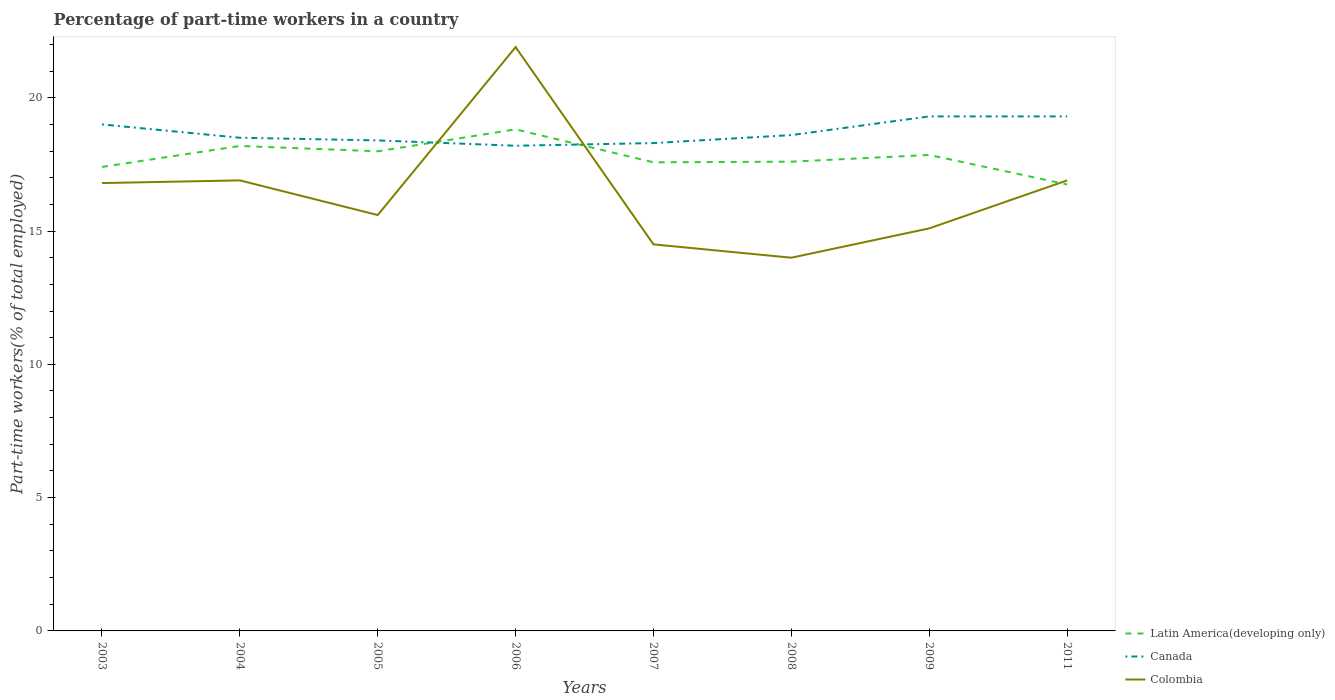How many different coloured lines are there?
Offer a terse response. 3. Does the line corresponding to Latin America(developing only) intersect with the line corresponding to Colombia?
Offer a terse response. Yes. Is the number of lines equal to the number of legend labels?
Offer a terse response. Yes. Across all years, what is the maximum percentage of part-time workers in Canada?
Your answer should be compact. 18.2. What is the total percentage of part-time workers in Colombia in the graph?
Ensure brevity in your answer.  2.9. What is the difference between the highest and the second highest percentage of part-time workers in Latin America(developing only)?
Offer a terse response. 2.07. How many lines are there?
Your response must be concise. 3. Does the graph contain any zero values?
Your answer should be very brief. No. How are the legend labels stacked?
Ensure brevity in your answer.  Vertical. What is the title of the graph?
Your answer should be very brief. Percentage of part-time workers in a country. What is the label or title of the Y-axis?
Ensure brevity in your answer.  Part-time workers(% of total employed). What is the Part-time workers(% of total employed) in Latin America(developing only) in 2003?
Make the answer very short. 17.4. What is the Part-time workers(% of total employed) in Canada in 2003?
Give a very brief answer. 19. What is the Part-time workers(% of total employed) of Colombia in 2003?
Make the answer very short. 16.8. What is the Part-time workers(% of total employed) of Latin America(developing only) in 2004?
Offer a very short reply. 18.19. What is the Part-time workers(% of total employed) in Canada in 2004?
Provide a succinct answer. 18.5. What is the Part-time workers(% of total employed) of Colombia in 2004?
Provide a short and direct response. 16.9. What is the Part-time workers(% of total employed) in Latin America(developing only) in 2005?
Give a very brief answer. 17.99. What is the Part-time workers(% of total employed) in Canada in 2005?
Ensure brevity in your answer.  18.4. What is the Part-time workers(% of total employed) in Colombia in 2005?
Offer a very short reply. 15.6. What is the Part-time workers(% of total employed) in Latin America(developing only) in 2006?
Provide a succinct answer. 18.81. What is the Part-time workers(% of total employed) in Canada in 2006?
Keep it short and to the point. 18.2. What is the Part-time workers(% of total employed) in Colombia in 2006?
Provide a succinct answer. 21.9. What is the Part-time workers(% of total employed) in Latin America(developing only) in 2007?
Offer a very short reply. 17.58. What is the Part-time workers(% of total employed) of Canada in 2007?
Provide a short and direct response. 18.3. What is the Part-time workers(% of total employed) in Latin America(developing only) in 2008?
Your response must be concise. 17.6. What is the Part-time workers(% of total employed) in Canada in 2008?
Your answer should be very brief. 18.6. What is the Part-time workers(% of total employed) in Colombia in 2008?
Give a very brief answer. 14. What is the Part-time workers(% of total employed) of Latin America(developing only) in 2009?
Ensure brevity in your answer.  17.85. What is the Part-time workers(% of total employed) of Canada in 2009?
Offer a very short reply. 19.3. What is the Part-time workers(% of total employed) in Colombia in 2009?
Your answer should be compact. 15.1. What is the Part-time workers(% of total employed) of Latin America(developing only) in 2011?
Your answer should be compact. 16.75. What is the Part-time workers(% of total employed) of Canada in 2011?
Make the answer very short. 19.3. What is the Part-time workers(% of total employed) in Colombia in 2011?
Your answer should be compact. 16.9. Across all years, what is the maximum Part-time workers(% of total employed) in Latin America(developing only)?
Provide a succinct answer. 18.81. Across all years, what is the maximum Part-time workers(% of total employed) of Canada?
Offer a terse response. 19.3. Across all years, what is the maximum Part-time workers(% of total employed) in Colombia?
Offer a terse response. 21.9. Across all years, what is the minimum Part-time workers(% of total employed) of Latin America(developing only)?
Offer a very short reply. 16.75. Across all years, what is the minimum Part-time workers(% of total employed) in Canada?
Your response must be concise. 18.2. What is the total Part-time workers(% of total employed) in Latin America(developing only) in the graph?
Your response must be concise. 142.19. What is the total Part-time workers(% of total employed) of Canada in the graph?
Make the answer very short. 149.6. What is the total Part-time workers(% of total employed) of Colombia in the graph?
Provide a succinct answer. 131.7. What is the difference between the Part-time workers(% of total employed) in Latin America(developing only) in 2003 and that in 2004?
Provide a short and direct response. -0.79. What is the difference between the Part-time workers(% of total employed) of Canada in 2003 and that in 2004?
Provide a succinct answer. 0.5. What is the difference between the Part-time workers(% of total employed) in Latin America(developing only) in 2003 and that in 2005?
Your response must be concise. -0.59. What is the difference between the Part-time workers(% of total employed) of Canada in 2003 and that in 2005?
Offer a very short reply. 0.6. What is the difference between the Part-time workers(% of total employed) in Colombia in 2003 and that in 2005?
Offer a very short reply. 1.2. What is the difference between the Part-time workers(% of total employed) of Latin America(developing only) in 2003 and that in 2006?
Your answer should be very brief. -1.41. What is the difference between the Part-time workers(% of total employed) in Canada in 2003 and that in 2006?
Your answer should be very brief. 0.8. What is the difference between the Part-time workers(% of total employed) in Latin America(developing only) in 2003 and that in 2007?
Keep it short and to the point. -0.17. What is the difference between the Part-time workers(% of total employed) in Colombia in 2003 and that in 2007?
Offer a very short reply. 2.3. What is the difference between the Part-time workers(% of total employed) of Latin America(developing only) in 2003 and that in 2008?
Provide a short and direct response. -0.2. What is the difference between the Part-time workers(% of total employed) of Canada in 2003 and that in 2008?
Offer a terse response. 0.4. What is the difference between the Part-time workers(% of total employed) in Colombia in 2003 and that in 2008?
Offer a terse response. 2.8. What is the difference between the Part-time workers(% of total employed) of Latin America(developing only) in 2003 and that in 2009?
Make the answer very short. -0.45. What is the difference between the Part-time workers(% of total employed) in Latin America(developing only) in 2003 and that in 2011?
Offer a terse response. 0.66. What is the difference between the Part-time workers(% of total employed) in Colombia in 2003 and that in 2011?
Offer a very short reply. -0.1. What is the difference between the Part-time workers(% of total employed) in Latin America(developing only) in 2004 and that in 2005?
Make the answer very short. 0.2. What is the difference between the Part-time workers(% of total employed) in Canada in 2004 and that in 2005?
Make the answer very short. 0.1. What is the difference between the Part-time workers(% of total employed) in Latin America(developing only) in 2004 and that in 2006?
Provide a short and direct response. -0.62. What is the difference between the Part-time workers(% of total employed) of Canada in 2004 and that in 2006?
Your response must be concise. 0.3. What is the difference between the Part-time workers(% of total employed) in Colombia in 2004 and that in 2006?
Make the answer very short. -5. What is the difference between the Part-time workers(% of total employed) of Latin America(developing only) in 2004 and that in 2007?
Make the answer very short. 0.61. What is the difference between the Part-time workers(% of total employed) in Latin America(developing only) in 2004 and that in 2008?
Make the answer very short. 0.59. What is the difference between the Part-time workers(% of total employed) of Colombia in 2004 and that in 2008?
Provide a succinct answer. 2.9. What is the difference between the Part-time workers(% of total employed) of Latin America(developing only) in 2004 and that in 2009?
Make the answer very short. 0.34. What is the difference between the Part-time workers(% of total employed) in Canada in 2004 and that in 2009?
Your answer should be compact. -0.8. What is the difference between the Part-time workers(% of total employed) of Latin America(developing only) in 2004 and that in 2011?
Offer a very short reply. 1.44. What is the difference between the Part-time workers(% of total employed) in Canada in 2004 and that in 2011?
Provide a succinct answer. -0.8. What is the difference between the Part-time workers(% of total employed) of Colombia in 2004 and that in 2011?
Make the answer very short. 0. What is the difference between the Part-time workers(% of total employed) in Latin America(developing only) in 2005 and that in 2006?
Offer a very short reply. -0.82. What is the difference between the Part-time workers(% of total employed) of Latin America(developing only) in 2005 and that in 2007?
Offer a terse response. 0.41. What is the difference between the Part-time workers(% of total employed) in Canada in 2005 and that in 2007?
Make the answer very short. 0.1. What is the difference between the Part-time workers(% of total employed) of Colombia in 2005 and that in 2007?
Ensure brevity in your answer.  1.1. What is the difference between the Part-time workers(% of total employed) in Latin America(developing only) in 2005 and that in 2008?
Your answer should be compact. 0.39. What is the difference between the Part-time workers(% of total employed) in Canada in 2005 and that in 2008?
Keep it short and to the point. -0.2. What is the difference between the Part-time workers(% of total employed) of Colombia in 2005 and that in 2008?
Provide a short and direct response. 1.6. What is the difference between the Part-time workers(% of total employed) of Latin America(developing only) in 2005 and that in 2009?
Provide a succinct answer. 0.14. What is the difference between the Part-time workers(% of total employed) of Canada in 2005 and that in 2009?
Your answer should be very brief. -0.9. What is the difference between the Part-time workers(% of total employed) in Latin America(developing only) in 2005 and that in 2011?
Make the answer very short. 1.24. What is the difference between the Part-time workers(% of total employed) in Colombia in 2005 and that in 2011?
Provide a short and direct response. -1.3. What is the difference between the Part-time workers(% of total employed) of Latin America(developing only) in 2006 and that in 2007?
Offer a very short reply. 1.24. What is the difference between the Part-time workers(% of total employed) of Colombia in 2006 and that in 2007?
Give a very brief answer. 7.4. What is the difference between the Part-time workers(% of total employed) of Latin America(developing only) in 2006 and that in 2008?
Offer a very short reply. 1.21. What is the difference between the Part-time workers(% of total employed) in Canada in 2006 and that in 2008?
Make the answer very short. -0.4. What is the difference between the Part-time workers(% of total employed) in Latin America(developing only) in 2006 and that in 2009?
Your answer should be very brief. 0.96. What is the difference between the Part-time workers(% of total employed) of Colombia in 2006 and that in 2009?
Provide a succinct answer. 6.8. What is the difference between the Part-time workers(% of total employed) of Latin America(developing only) in 2006 and that in 2011?
Provide a short and direct response. 2.07. What is the difference between the Part-time workers(% of total employed) of Colombia in 2006 and that in 2011?
Offer a terse response. 5. What is the difference between the Part-time workers(% of total employed) of Latin America(developing only) in 2007 and that in 2008?
Your response must be concise. -0.02. What is the difference between the Part-time workers(% of total employed) in Colombia in 2007 and that in 2008?
Your answer should be compact. 0.5. What is the difference between the Part-time workers(% of total employed) of Latin America(developing only) in 2007 and that in 2009?
Provide a succinct answer. -0.27. What is the difference between the Part-time workers(% of total employed) of Colombia in 2007 and that in 2009?
Keep it short and to the point. -0.6. What is the difference between the Part-time workers(% of total employed) of Latin America(developing only) in 2007 and that in 2011?
Your answer should be very brief. 0.83. What is the difference between the Part-time workers(% of total employed) in Canada in 2007 and that in 2011?
Make the answer very short. -1. What is the difference between the Part-time workers(% of total employed) in Colombia in 2007 and that in 2011?
Provide a short and direct response. -2.4. What is the difference between the Part-time workers(% of total employed) in Latin America(developing only) in 2008 and that in 2009?
Offer a very short reply. -0.25. What is the difference between the Part-time workers(% of total employed) in Canada in 2008 and that in 2009?
Ensure brevity in your answer.  -0.7. What is the difference between the Part-time workers(% of total employed) in Latin America(developing only) in 2008 and that in 2011?
Ensure brevity in your answer.  0.85. What is the difference between the Part-time workers(% of total employed) in Canada in 2008 and that in 2011?
Keep it short and to the point. -0.7. What is the difference between the Part-time workers(% of total employed) of Colombia in 2008 and that in 2011?
Offer a terse response. -2.9. What is the difference between the Part-time workers(% of total employed) of Latin America(developing only) in 2009 and that in 2011?
Your response must be concise. 1.11. What is the difference between the Part-time workers(% of total employed) of Colombia in 2009 and that in 2011?
Keep it short and to the point. -1.8. What is the difference between the Part-time workers(% of total employed) of Latin America(developing only) in 2003 and the Part-time workers(% of total employed) of Canada in 2004?
Provide a short and direct response. -1.1. What is the difference between the Part-time workers(% of total employed) of Latin America(developing only) in 2003 and the Part-time workers(% of total employed) of Colombia in 2004?
Provide a short and direct response. 0.5. What is the difference between the Part-time workers(% of total employed) in Latin America(developing only) in 2003 and the Part-time workers(% of total employed) in Canada in 2005?
Ensure brevity in your answer.  -1. What is the difference between the Part-time workers(% of total employed) in Latin America(developing only) in 2003 and the Part-time workers(% of total employed) in Colombia in 2005?
Give a very brief answer. 1.8. What is the difference between the Part-time workers(% of total employed) of Latin America(developing only) in 2003 and the Part-time workers(% of total employed) of Canada in 2006?
Ensure brevity in your answer.  -0.8. What is the difference between the Part-time workers(% of total employed) of Latin America(developing only) in 2003 and the Part-time workers(% of total employed) of Colombia in 2006?
Your answer should be very brief. -4.5. What is the difference between the Part-time workers(% of total employed) of Latin America(developing only) in 2003 and the Part-time workers(% of total employed) of Canada in 2007?
Make the answer very short. -0.9. What is the difference between the Part-time workers(% of total employed) of Latin America(developing only) in 2003 and the Part-time workers(% of total employed) of Colombia in 2007?
Your answer should be very brief. 2.9. What is the difference between the Part-time workers(% of total employed) of Canada in 2003 and the Part-time workers(% of total employed) of Colombia in 2007?
Provide a short and direct response. 4.5. What is the difference between the Part-time workers(% of total employed) in Latin America(developing only) in 2003 and the Part-time workers(% of total employed) in Canada in 2008?
Your answer should be very brief. -1.2. What is the difference between the Part-time workers(% of total employed) of Latin America(developing only) in 2003 and the Part-time workers(% of total employed) of Colombia in 2008?
Keep it short and to the point. 3.4. What is the difference between the Part-time workers(% of total employed) of Latin America(developing only) in 2003 and the Part-time workers(% of total employed) of Canada in 2009?
Offer a very short reply. -1.9. What is the difference between the Part-time workers(% of total employed) in Latin America(developing only) in 2003 and the Part-time workers(% of total employed) in Colombia in 2009?
Your response must be concise. 2.3. What is the difference between the Part-time workers(% of total employed) in Canada in 2003 and the Part-time workers(% of total employed) in Colombia in 2009?
Provide a succinct answer. 3.9. What is the difference between the Part-time workers(% of total employed) of Latin America(developing only) in 2003 and the Part-time workers(% of total employed) of Canada in 2011?
Your answer should be very brief. -1.9. What is the difference between the Part-time workers(% of total employed) in Latin America(developing only) in 2003 and the Part-time workers(% of total employed) in Colombia in 2011?
Your answer should be compact. 0.5. What is the difference between the Part-time workers(% of total employed) of Canada in 2003 and the Part-time workers(% of total employed) of Colombia in 2011?
Give a very brief answer. 2.1. What is the difference between the Part-time workers(% of total employed) of Latin America(developing only) in 2004 and the Part-time workers(% of total employed) of Canada in 2005?
Give a very brief answer. -0.21. What is the difference between the Part-time workers(% of total employed) of Latin America(developing only) in 2004 and the Part-time workers(% of total employed) of Colombia in 2005?
Provide a short and direct response. 2.59. What is the difference between the Part-time workers(% of total employed) of Latin America(developing only) in 2004 and the Part-time workers(% of total employed) of Canada in 2006?
Offer a terse response. -0.01. What is the difference between the Part-time workers(% of total employed) of Latin America(developing only) in 2004 and the Part-time workers(% of total employed) of Colombia in 2006?
Keep it short and to the point. -3.71. What is the difference between the Part-time workers(% of total employed) of Canada in 2004 and the Part-time workers(% of total employed) of Colombia in 2006?
Give a very brief answer. -3.4. What is the difference between the Part-time workers(% of total employed) of Latin America(developing only) in 2004 and the Part-time workers(% of total employed) of Canada in 2007?
Keep it short and to the point. -0.11. What is the difference between the Part-time workers(% of total employed) of Latin America(developing only) in 2004 and the Part-time workers(% of total employed) of Colombia in 2007?
Your answer should be compact. 3.69. What is the difference between the Part-time workers(% of total employed) in Canada in 2004 and the Part-time workers(% of total employed) in Colombia in 2007?
Your response must be concise. 4. What is the difference between the Part-time workers(% of total employed) of Latin America(developing only) in 2004 and the Part-time workers(% of total employed) of Canada in 2008?
Your response must be concise. -0.41. What is the difference between the Part-time workers(% of total employed) in Latin America(developing only) in 2004 and the Part-time workers(% of total employed) in Colombia in 2008?
Keep it short and to the point. 4.19. What is the difference between the Part-time workers(% of total employed) of Canada in 2004 and the Part-time workers(% of total employed) of Colombia in 2008?
Give a very brief answer. 4.5. What is the difference between the Part-time workers(% of total employed) of Latin America(developing only) in 2004 and the Part-time workers(% of total employed) of Canada in 2009?
Provide a short and direct response. -1.11. What is the difference between the Part-time workers(% of total employed) in Latin America(developing only) in 2004 and the Part-time workers(% of total employed) in Colombia in 2009?
Your answer should be very brief. 3.09. What is the difference between the Part-time workers(% of total employed) of Canada in 2004 and the Part-time workers(% of total employed) of Colombia in 2009?
Offer a very short reply. 3.4. What is the difference between the Part-time workers(% of total employed) in Latin America(developing only) in 2004 and the Part-time workers(% of total employed) in Canada in 2011?
Your answer should be very brief. -1.11. What is the difference between the Part-time workers(% of total employed) of Latin America(developing only) in 2004 and the Part-time workers(% of total employed) of Colombia in 2011?
Offer a terse response. 1.29. What is the difference between the Part-time workers(% of total employed) of Canada in 2004 and the Part-time workers(% of total employed) of Colombia in 2011?
Your answer should be very brief. 1.6. What is the difference between the Part-time workers(% of total employed) of Latin America(developing only) in 2005 and the Part-time workers(% of total employed) of Canada in 2006?
Give a very brief answer. -0.21. What is the difference between the Part-time workers(% of total employed) in Latin America(developing only) in 2005 and the Part-time workers(% of total employed) in Colombia in 2006?
Make the answer very short. -3.91. What is the difference between the Part-time workers(% of total employed) of Canada in 2005 and the Part-time workers(% of total employed) of Colombia in 2006?
Give a very brief answer. -3.5. What is the difference between the Part-time workers(% of total employed) of Latin America(developing only) in 2005 and the Part-time workers(% of total employed) of Canada in 2007?
Provide a succinct answer. -0.31. What is the difference between the Part-time workers(% of total employed) of Latin America(developing only) in 2005 and the Part-time workers(% of total employed) of Colombia in 2007?
Ensure brevity in your answer.  3.49. What is the difference between the Part-time workers(% of total employed) in Latin America(developing only) in 2005 and the Part-time workers(% of total employed) in Canada in 2008?
Keep it short and to the point. -0.61. What is the difference between the Part-time workers(% of total employed) of Latin America(developing only) in 2005 and the Part-time workers(% of total employed) of Colombia in 2008?
Offer a very short reply. 3.99. What is the difference between the Part-time workers(% of total employed) of Latin America(developing only) in 2005 and the Part-time workers(% of total employed) of Canada in 2009?
Your answer should be compact. -1.31. What is the difference between the Part-time workers(% of total employed) in Latin America(developing only) in 2005 and the Part-time workers(% of total employed) in Colombia in 2009?
Your answer should be very brief. 2.89. What is the difference between the Part-time workers(% of total employed) in Canada in 2005 and the Part-time workers(% of total employed) in Colombia in 2009?
Ensure brevity in your answer.  3.3. What is the difference between the Part-time workers(% of total employed) of Latin America(developing only) in 2005 and the Part-time workers(% of total employed) of Canada in 2011?
Offer a terse response. -1.31. What is the difference between the Part-time workers(% of total employed) in Latin America(developing only) in 2005 and the Part-time workers(% of total employed) in Colombia in 2011?
Your answer should be very brief. 1.09. What is the difference between the Part-time workers(% of total employed) in Canada in 2005 and the Part-time workers(% of total employed) in Colombia in 2011?
Your answer should be very brief. 1.5. What is the difference between the Part-time workers(% of total employed) in Latin America(developing only) in 2006 and the Part-time workers(% of total employed) in Canada in 2007?
Your answer should be very brief. 0.51. What is the difference between the Part-time workers(% of total employed) of Latin America(developing only) in 2006 and the Part-time workers(% of total employed) of Colombia in 2007?
Your answer should be very brief. 4.31. What is the difference between the Part-time workers(% of total employed) in Latin America(developing only) in 2006 and the Part-time workers(% of total employed) in Canada in 2008?
Give a very brief answer. 0.21. What is the difference between the Part-time workers(% of total employed) of Latin America(developing only) in 2006 and the Part-time workers(% of total employed) of Colombia in 2008?
Keep it short and to the point. 4.81. What is the difference between the Part-time workers(% of total employed) in Latin America(developing only) in 2006 and the Part-time workers(% of total employed) in Canada in 2009?
Your answer should be very brief. -0.49. What is the difference between the Part-time workers(% of total employed) of Latin America(developing only) in 2006 and the Part-time workers(% of total employed) of Colombia in 2009?
Ensure brevity in your answer.  3.71. What is the difference between the Part-time workers(% of total employed) in Canada in 2006 and the Part-time workers(% of total employed) in Colombia in 2009?
Your answer should be compact. 3.1. What is the difference between the Part-time workers(% of total employed) of Latin America(developing only) in 2006 and the Part-time workers(% of total employed) of Canada in 2011?
Your answer should be compact. -0.49. What is the difference between the Part-time workers(% of total employed) in Latin America(developing only) in 2006 and the Part-time workers(% of total employed) in Colombia in 2011?
Ensure brevity in your answer.  1.91. What is the difference between the Part-time workers(% of total employed) in Canada in 2006 and the Part-time workers(% of total employed) in Colombia in 2011?
Ensure brevity in your answer.  1.3. What is the difference between the Part-time workers(% of total employed) in Latin America(developing only) in 2007 and the Part-time workers(% of total employed) in Canada in 2008?
Give a very brief answer. -1.02. What is the difference between the Part-time workers(% of total employed) of Latin America(developing only) in 2007 and the Part-time workers(% of total employed) of Colombia in 2008?
Your response must be concise. 3.58. What is the difference between the Part-time workers(% of total employed) in Latin America(developing only) in 2007 and the Part-time workers(% of total employed) in Canada in 2009?
Give a very brief answer. -1.72. What is the difference between the Part-time workers(% of total employed) of Latin America(developing only) in 2007 and the Part-time workers(% of total employed) of Colombia in 2009?
Offer a very short reply. 2.48. What is the difference between the Part-time workers(% of total employed) of Canada in 2007 and the Part-time workers(% of total employed) of Colombia in 2009?
Provide a short and direct response. 3.2. What is the difference between the Part-time workers(% of total employed) in Latin America(developing only) in 2007 and the Part-time workers(% of total employed) in Canada in 2011?
Your answer should be very brief. -1.72. What is the difference between the Part-time workers(% of total employed) of Latin America(developing only) in 2007 and the Part-time workers(% of total employed) of Colombia in 2011?
Make the answer very short. 0.68. What is the difference between the Part-time workers(% of total employed) in Canada in 2007 and the Part-time workers(% of total employed) in Colombia in 2011?
Offer a very short reply. 1.4. What is the difference between the Part-time workers(% of total employed) of Latin America(developing only) in 2008 and the Part-time workers(% of total employed) of Canada in 2009?
Keep it short and to the point. -1.7. What is the difference between the Part-time workers(% of total employed) in Latin America(developing only) in 2008 and the Part-time workers(% of total employed) in Colombia in 2009?
Your answer should be very brief. 2.5. What is the difference between the Part-time workers(% of total employed) in Latin America(developing only) in 2008 and the Part-time workers(% of total employed) in Canada in 2011?
Keep it short and to the point. -1.7. What is the difference between the Part-time workers(% of total employed) in Latin America(developing only) in 2008 and the Part-time workers(% of total employed) in Colombia in 2011?
Your answer should be very brief. 0.7. What is the difference between the Part-time workers(% of total employed) in Latin America(developing only) in 2009 and the Part-time workers(% of total employed) in Canada in 2011?
Provide a succinct answer. -1.45. What is the difference between the Part-time workers(% of total employed) in Latin America(developing only) in 2009 and the Part-time workers(% of total employed) in Colombia in 2011?
Offer a terse response. 0.95. What is the average Part-time workers(% of total employed) of Latin America(developing only) per year?
Make the answer very short. 17.77. What is the average Part-time workers(% of total employed) in Canada per year?
Your response must be concise. 18.7. What is the average Part-time workers(% of total employed) in Colombia per year?
Keep it short and to the point. 16.46. In the year 2003, what is the difference between the Part-time workers(% of total employed) in Latin America(developing only) and Part-time workers(% of total employed) in Canada?
Ensure brevity in your answer.  -1.6. In the year 2003, what is the difference between the Part-time workers(% of total employed) of Latin America(developing only) and Part-time workers(% of total employed) of Colombia?
Give a very brief answer. 0.6. In the year 2004, what is the difference between the Part-time workers(% of total employed) in Latin America(developing only) and Part-time workers(% of total employed) in Canada?
Ensure brevity in your answer.  -0.31. In the year 2004, what is the difference between the Part-time workers(% of total employed) of Latin America(developing only) and Part-time workers(% of total employed) of Colombia?
Your answer should be compact. 1.29. In the year 2004, what is the difference between the Part-time workers(% of total employed) in Canada and Part-time workers(% of total employed) in Colombia?
Offer a very short reply. 1.6. In the year 2005, what is the difference between the Part-time workers(% of total employed) of Latin America(developing only) and Part-time workers(% of total employed) of Canada?
Offer a very short reply. -0.41. In the year 2005, what is the difference between the Part-time workers(% of total employed) of Latin America(developing only) and Part-time workers(% of total employed) of Colombia?
Ensure brevity in your answer.  2.39. In the year 2005, what is the difference between the Part-time workers(% of total employed) of Canada and Part-time workers(% of total employed) of Colombia?
Give a very brief answer. 2.8. In the year 2006, what is the difference between the Part-time workers(% of total employed) in Latin America(developing only) and Part-time workers(% of total employed) in Canada?
Your answer should be compact. 0.61. In the year 2006, what is the difference between the Part-time workers(% of total employed) of Latin America(developing only) and Part-time workers(% of total employed) of Colombia?
Keep it short and to the point. -3.09. In the year 2006, what is the difference between the Part-time workers(% of total employed) in Canada and Part-time workers(% of total employed) in Colombia?
Your answer should be very brief. -3.7. In the year 2007, what is the difference between the Part-time workers(% of total employed) in Latin America(developing only) and Part-time workers(% of total employed) in Canada?
Make the answer very short. -0.72. In the year 2007, what is the difference between the Part-time workers(% of total employed) of Latin America(developing only) and Part-time workers(% of total employed) of Colombia?
Provide a short and direct response. 3.08. In the year 2007, what is the difference between the Part-time workers(% of total employed) in Canada and Part-time workers(% of total employed) in Colombia?
Make the answer very short. 3.8. In the year 2008, what is the difference between the Part-time workers(% of total employed) in Latin America(developing only) and Part-time workers(% of total employed) in Canada?
Make the answer very short. -1. In the year 2008, what is the difference between the Part-time workers(% of total employed) in Latin America(developing only) and Part-time workers(% of total employed) in Colombia?
Ensure brevity in your answer.  3.6. In the year 2008, what is the difference between the Part-time workers(% of total employed) of Canada and Part-time workers(% of total employed) of Colombia?
Your response must be concise. 4.6. In the year 2009, what is the difference between the Part-time workers(% of total employed) in Latin America(developing only) and Part-time workers(% of total employed) in Canada?
Give a very brief answer. -1.45. In the year 2009, what is the difference between the Part-time workers(% of total employed) in Latin America(developing only) and Part-time workers(% of total employed) in Colombia?
Provide a short and direct response. 2.75. In the year 2009, what is the difference between the Part-time workers(% of total employed) of Canada and Part-time workers(% of total employed) of Colombia?
Give a very brief answer. 4.2. In the year 2011, what is the difference between the Part-time workers(% of total employed) in Latin America(developing only) and Part-time workers(% of total employed) in Canada?
Offer a terse response. -2.55. In the year 2011, what is the difference between the Part-time workers(% of total employed) of Latin America(developing only) and Part-time workers(% of total employed) of Colombia?
Your response must be concise. -0.15. What is the ratio of the Part-time workers(% of total employed) in Latin America(developing only) in 2003 to that in 2004?
Offer a terse response. 0.96. What is the ratio of the Part-time workers(% of total employed) in Latin America(developing only) in 2003 to that in 2005?
Your answer should be very brief. 0.97. What is the ratio of the Part-time workers(% of total employed) of Canada in 2003 to that in 2005?
Your response must be concise. 1.03. What is the ratio of the Part-time workers(% of total employed) in Latin America(developing only) in 2003 to that in 2006?
Keep it short and to the point. 0.93. What is the ratio of the Part-time workers(% of total employed) in Canada in 2003 to that in 2006?
Offer a very short reply. 1.04. What is the ratio of the Part-time workers(% of total employed) in Colombia in 2003 to that in 2006?
Give a very brief answer. 0.77. What is the ratio of the Part-time workers(% of total employed) of Latin America(developing only) in 2003 to that in 2007?
Make the answer very short. 0.99. What is the ratio of the Part-time workers(% of total employed) of Canada in 2003 to that in 2007?
Your answer should be very brief. 1.04. What is the ratio of the Part-time workers(% of total employed) in Colombia in 2003 to that in 2007?
Keep it short and to the point. 1.16. What is the ratio of the Part-time workers(% of total employed) of Canada in 2003 to that in 2008?
Your response must be concise. 1.02. What is the ratio of the Part-time workers(% of total employed) of Latin America(developing only) in 2003 to that in 2009?
Make the answer very short. 0.97. What is the ratio of the Part-time workers(% of total employed) of Canada in 2003 to that in 2009?
Your answer should be compact. 0.98. What is the ratio of the Part-time workers(% of total employed) of Colombia in 2003 to that in 2009?
Provide a succinct answer. 1.11. What is the ratio of the Part-time workers(% of total employed) in Latin America(developing only) in 2003 to that in 2011?
Make the answer very short. 1.04. What is the ratio of the Part-time workers(% of total employed) of Canada in 2003 to that in 2011?
Offer a very short reply. 0.98. What is the ratio of the Part-time workers(% of total employed) in Colombia in 2003 to that in 2011?
Your answer should be compact. 0.99. What is the ratio of the Part-time workers(% of total employed) of Latin America(developing only) in 2004 to that in 2005?
Give a very brief answer. 1.01. What is the ratio of the Part-time workers(% of total employed) of Canada in 2004 to that in 2005?
Offer a very short reply. 1.01. What is the ratio of the Part-time workers(% of total employed) in Colombia in 2004 to that in 2005?
Your answer should be compact. 1.08. What is the ratio of the Part-time workers(% of total employed) in Latin America(developing only) in 2004 to that in 2006?
Offer a very short reply. 0.97. What is the ratio of the Part-time workers(% of total employed) of Canada in 2004 to that in 2006?
Your answer should be compact. 1.02. What is the ratio of the Part-time workers(% of total employed) in Colombia in 2004 to that in 2006?
Provide a succinct answer. 0.77. What is the ratio of the Part-time workers(% of total employed) of Latin America(developing only) in 2004 to that in 2007?
Ensure brevity in your answer.  1.03. What is the ratio of the Part-time workers(% of total employed) of Canada in 2004 to that in 2007?
Your answer should be very brief. 1.01. What is the ratio of the Part-time workers(% of total employed) in Colombia in 2004 to that in 2007?
Keep it short and to the point. 1.17. What is the ratio of the Part-time workers(% of total employed) of Latin America(developing only) in 2004 to that in 2008?
Make the answer very short. 1.03. What is the ratio of the Part-time workers(% of total employed) of Canada in 2004 to that in 2008?
Provide a short and direct response. 0.99. What is the ratio of the Part-time workers(% of total employed) of Colombia in 2004 to that in 2008?
Provide a succinct answer. 1.21. What is the ratio of the Part-time workers(% of total employed) of Latin America(developing only) in 2004 to that in 2009?
Your response must be concise. 1.02. What is the ratio of the Part-time workers(% of total employed) of Canada in 2004 to that in 2009?
Offer a very short reply. 0.96. What is the ratio of the Part-time workers(% of total employed) in Colombia in 2004 to that in 2009?
Keep it short and to the point. 1.12. What is the ratio of the Part-time workers(% of total employed) of Latin America(developing only) in 2004 to that in 2011?
Offer a terse response. 1.09. What is the ratio of the Part-time workers(% of total employed) in Canada in 2004 to that in 2011?
Offer a very short reply. 0.96. What is the ratio of the Part-time workers(% of total employed) in Colombia in 2004 to that in 2011?
Make the answer very short. 1. What is the ratio of the Part-time workers(% of total employed) of Latin America(developing only) in 2005 to that in 2006?
Provide a short and direct response. 0.96. What is the ratio of the Part-time workers(% of total employed) of Colombia in 2005 to that in 2006?
Your response must be concise. 0.71. What is the ratio of the Part-time workers(% of total employed) of Latin America(developing only) in 2005 to that in 2007?
Offer a very short reply. 1.02. What is the ratio of the Part-time workers(% of total employed) of Canada in 2005 to that in 2007?
Provide a succinct answer. 1.01. What is the ratio of the Part-time workers(% of total employed) in Colombia in 2005 to that in 2007?
Provide a short and direct response. 1.08. What is the ratio of the Part-time workers(% of total employed) in Latin America(developing only) in 2005 to that in 2008?
Ensure brevity in your answer.  1.02. What is the ratio of the Part-time workers(% of total employed) in Colombia in 2005 to that in 2008?
Give a very brief answer. 1.11. What is the ratio of the Part-time workers(% of total employed) in Latin America(developing only) in 2005 to that in 2009?
Offer a very short reply. 1.01. What is the ratio of the Part-time workers(% of total employed) of Canada in 2005 to that in 2009?
Your response must be concise. 0.95. What is the ratio of the Part-time workers(% of total employed) in Colombia in 2005 to that in 2009?
Offer a very short reply. 1.03. What is the ratio of the Part-time workers(% of total employed) of Latin America(developing only) in 2005 to that in 2011?
Ensure brevity in your answer.  1.07. What is the ratio of the Part-time workers(% of total employed) of Canada in 2005 to that in 2011?
Your answer should be very brief. 0.95. What is the ratio of the Part-time workers(% of total employed) in Colombia in 2005 to that in 2011?
Your answer should be compact. 0.92. What is the ratio of the Part-time workers(% of total employed) of Latin America(developing only) in 2006 to that in 2007?
Your response must be concise. 1.07. What is the ratio of the Part-time workers(% of total employed) of Colombia in 2006 to that in 2007?
Offer a very short reply. 1.51. What is the ratio of the Part-time workers(% of total employed) in Latin America(developing only) in 2006 to that in 2008?
Provide a short and direct response. 1.07. What is the ratio of the Part-time workers(% of total employed) of Canada in 2006 to that in 2008?
Make the answer very short. 0.98. What is the ratio of the Part-time workers(% of total employed) of Colombia in 2006 to that in 2008?
Offer a very short reply. 1.56. What is the ratio of the Part-time workers(% of total employed) of Latin America(developing only) in 2006 to that in 2009?
Give a very brief answer. 1.05. What is the ratio of the Part-time workers(% of total employed) in Canada in 2006 to that in 2009?
Provide a short and direct response. 0.94. What is the ratio of the Part-time workers(% of total employed) in Colombia in 2006 to that in 2009?
Keep it short and to the point. 1.45. What is the ratio of the Part-time workers(% of total employed) in Latin America(developing only) in 2006 to that in 2011?
Provide a succinct answer. 1.12. What is the ratio of the Part-time workers(% of total employed) of Canada in 2006 to that in 2011?
Make the answer very short. 0.94. What is the ratio of the Part-time workers(% of total employed) in Colombia in 2006 to that in 2011?
Offer a terse response. 1.3. What is the ratio of the Part-time workers(% of total employed) in Canada in 2007 to that in 2008?
Make the answer very short. 0.98. What is the ratio of the Part-time workers(% of total employed) of Colombia in 2007 to that in 2008?
Offer a terse response. 1.04. What is the ratio of the Part-time workers(% of total employed) in Latin America(developing only) in 2007 to that in 2009?
Provide a succinct answer. 0.98. What is the ratio of the Part-time workers(% of total employed) of Canada in 2007 to that in 2009?
Ensure brevity in your answer.  0.95. What is the ratio of the Part-time workers(% of total employed) of Colombia in 2007 to that in 2009?
Provide a short and direct response. 0.96. What is the ratio of the Part-time workers(% of total employed) of Latin America(developing only) in 2007 to that in 2011?
Provide a succinct answer. 1.05. What is the ratio of the Part-time workers(% of total employed) in Canada in 2007 to that in 2011?
Provide a short and direct response. 0.95. What is the ratio of the Part-time workers(% of total employed) of Colombia in 2007 to that in 2011?
Offer a very short reply. 0.86. What is the ratio of the Part-time workers(% of total employed) of Latin America(developing only) in 2008 to that in 2009?
Give a very brief answer. 0.99. What is the ratio of the Part-time workers(% of total employed) of Canada in 2008 to that in 2009?
Keep it short and to the point. 0.96. What is the ratio of the Part-time workers(% of total employed) in Colombia in 2008 to that in 2009?
Your answer should be very brief. 0.93. What is the ratio of the Part-time workers(% of total employed) of Latin America(developing only) in 2008 to that in 2011?
Your answer should be compact. 1.05. What is the ratio of the Part-time workers(% of total employed) of Canada in 2008 to that in 2011?
Offer a very short reply. 0.96. What is the ratio of the Part-time workers(% of total employed) in Colombia in 2008 to that in 2011?
Give a very brief answer. 0.83. What is the ratio of the Part-time workers(% of total employed) of Latin America(developing only) in 2009 to that in 2011?
Your answer should be compact. 1.07. What is the ratio of the Part-time workers(% of total employed) of Canada in 2009 to that in 2011?
Your answer should be very brief. 1. What is the ratio of the Part-time workers(% of total employed) in Colombia in 2009 to that in 2011?
Offer a terse response. 0.89. What is the difference between the highest and the second highest Part-time workers(% of total employed) in Latin America(developing only)?
Ensure brevity in your answer.  0.62. What is the difference between the highest and the lowest Part-time workers(% of total employed) in Latin America(developing only)?
Offer a very short reply. 2.07. What is the difference between the highest and the lowest Part-time workers(% of total employed) of Canada?
Provide a short and direct response. 1.1. What is the difference between the highest and the lowest Part-time workers(% of total employed) of Colombia?
Give a very brief answer. 7.9. 